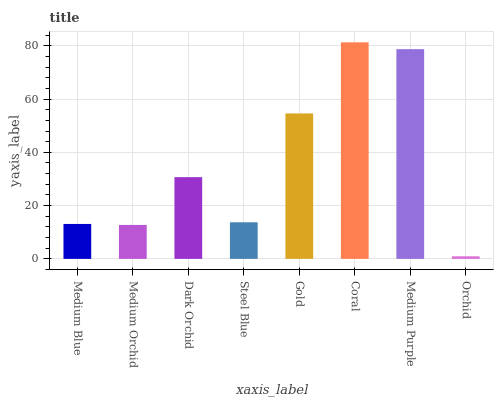Is Medium Orchid the minimum?
Answer yes or no. No. Is Medium Orchid the maximum?
Answer yes or no. No. Is Medium Blue greater than Medium Orchid?
Answer yes or no. Yes. Is Medium Orchid less than Medium Blue?
Answer yes or no. Yes. Is Medium Orchid greater than Medium Blue?
Answer yes or no. No. Is Medium Blue less than Medium Orchid?
Answer yes or no. No. Is Dark Orchid the high median?
Answer yes or no. Yes. Is Steel Blue the low median?
Answer yes or no. Yes. Is Coral the high median?
Answer yes or no. No. Is Orchid the low median?
Answer yes or no. No. 